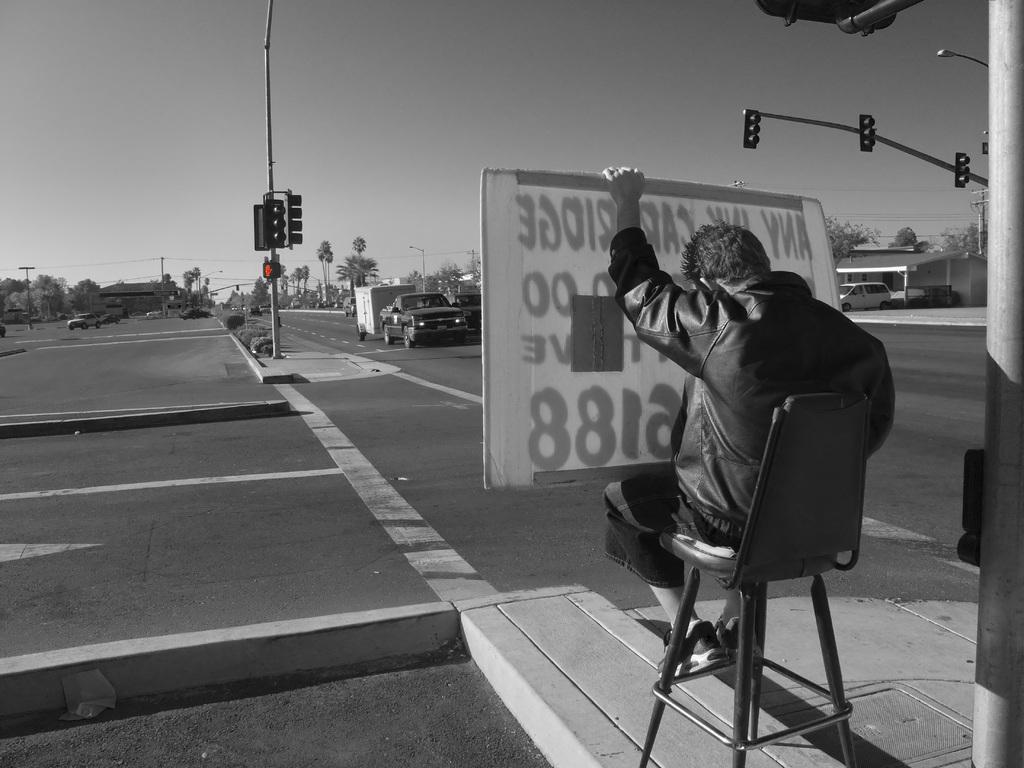Could you give a brief overview of what you see in this image? This is an edited image. In this image we can see a person sitting on the chair and holding an advertisement board in his hands, traffic poles, traffic signals, motor vehicles on the road, electric poles, electric lights, bushes, trees and sky. 